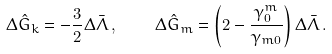Convert formula to latex. <formula><loc_0><loc_0><loc_500><loc_500>\Delta \hat { G } _ { k } = - \frac { 3 } { 2 } \Delta \bar { \Lambda } \, , \quad \Delta \hat { G } _ { m } = \left ( 2 - \frac { \gamma ^ { m } _ { 0 } } { \gamma _ { m 0 } } \right ) \Delta \bar { \Lambda } \, .</formula> 